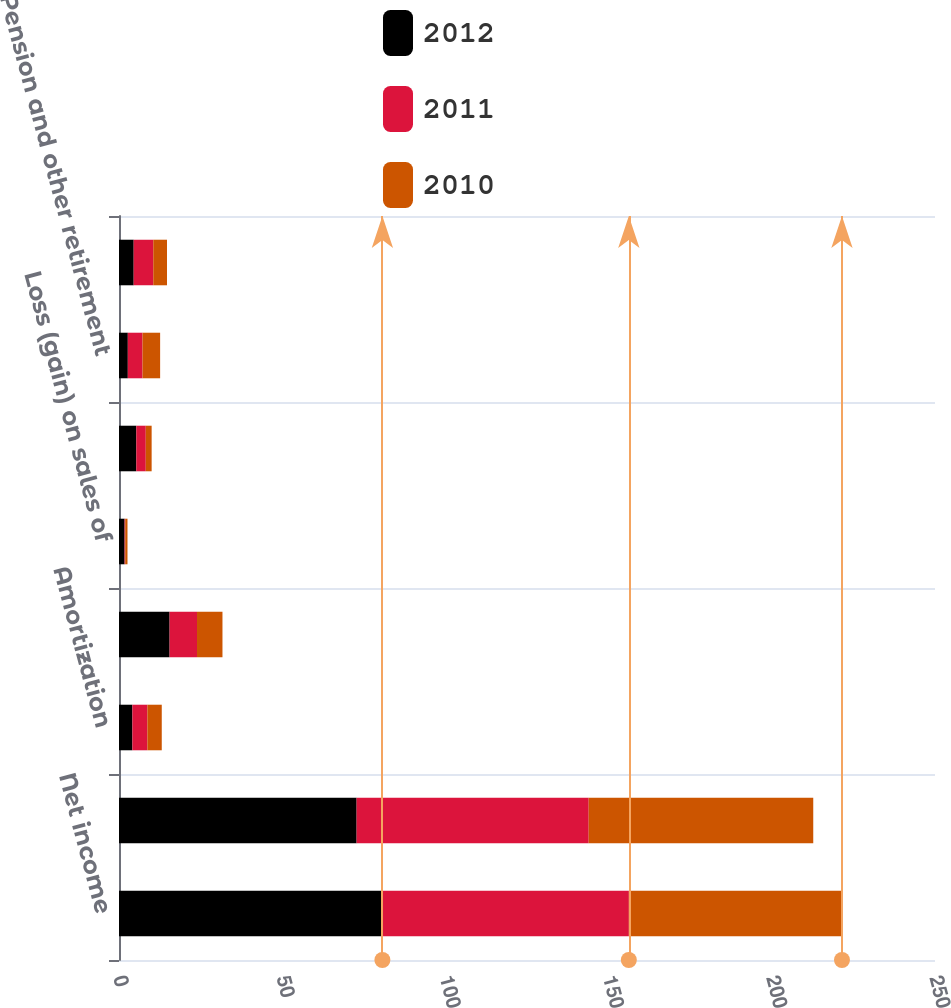Convert chart. <chart><loc_0><loc_0><loc_500><loc_500><stacked_bar_chart><ecel><fcel>Net income<fcel>Depreciation<fcel>Amortization<fcel>Stock-based compensation<fcel>Loss (gain) on sales of<fcel>Deferred income taxes<fcel>Pension and other retirement<fcel>Equity in undistributed<nl><fcel>2012<fcel>80.7<fcel>72.8<fcel>4.1<fcel>15.5<fcel>1.7<fcel>5.3<fcel>2.7<fcel>4.5<nl><fcel>2011<fcel>75.5<fcel>71.1<fcel>4.6<fcel>8.4<fcel>0.2<fcel>2.9<fcel>4.5<fcel>6<nl><fcel>2010<fcel>65.3<fcel>68.8<fcel>4.4<fcel>7.8<fcel>0.7<fcel>1.8<fcel>5.4<fcel>4.2<nl></chart> 